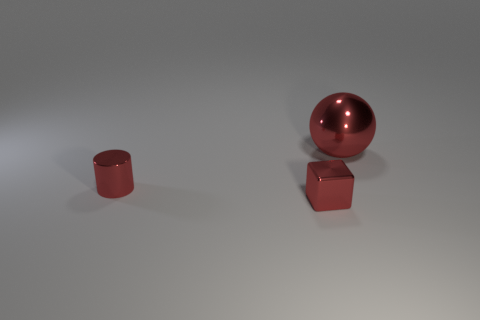The cylinder that is made of the same material as the small red block is what color? The cylinder shares the same lustrous, rich red hue as the smaller block, indicating that the reflected light and surface characteristics of both objects are consistent, suggesting they are made of the same material. 